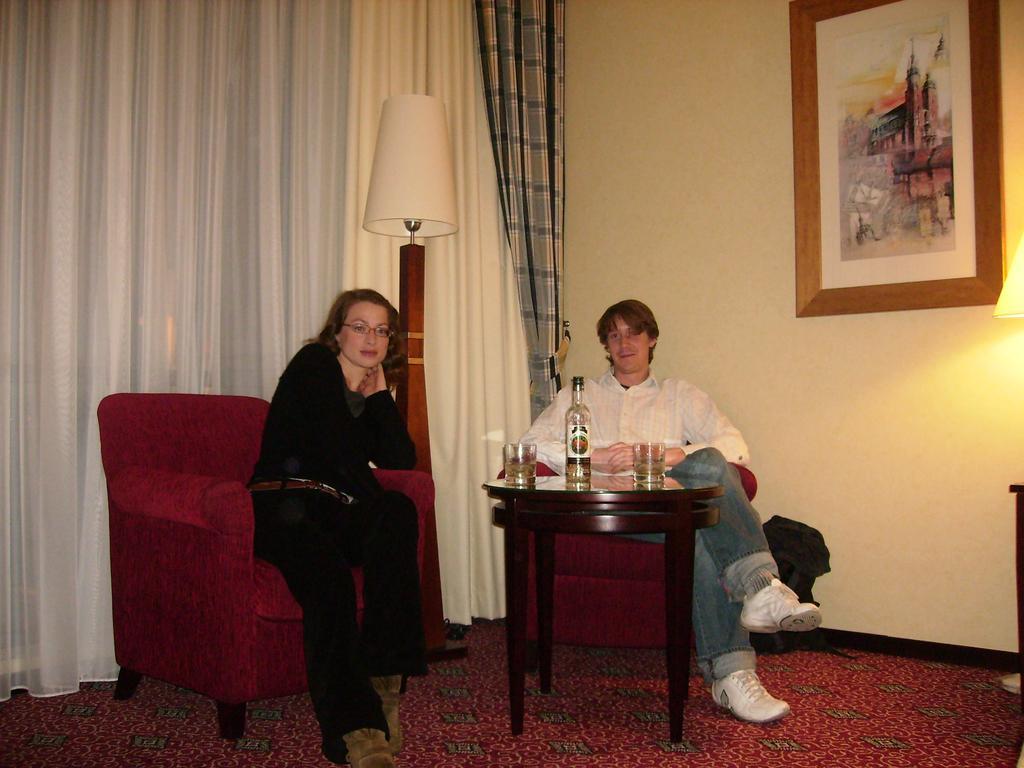Describe this image in one or two sentences. As we can see in the image there are two people sitting on sofa. In front of them there is a table. On table there are glasses and a bottle and there is a lamp over here, a white color curtain and yellow color wall. 